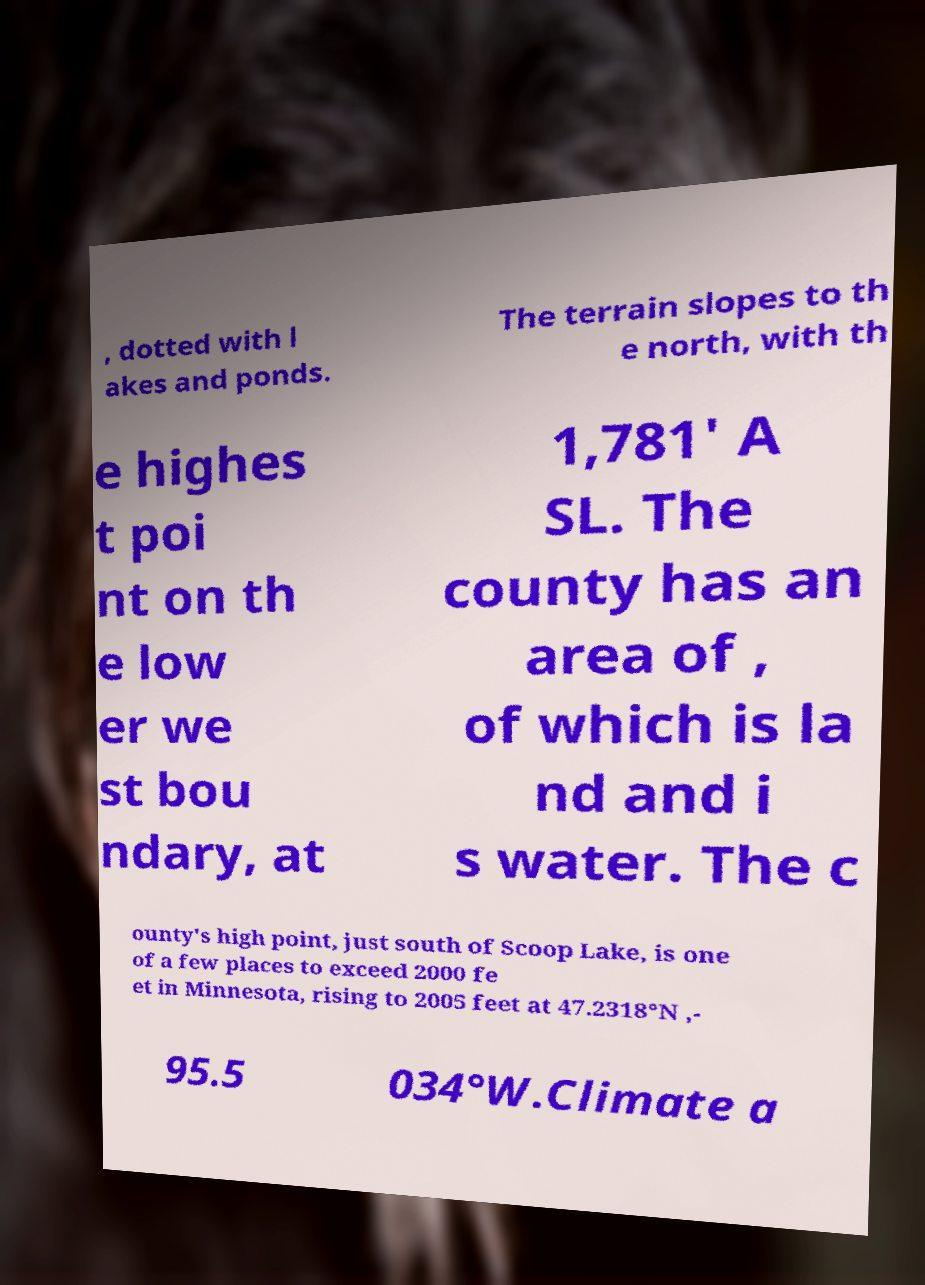Could you extract and type out the text from this image? , dotted with l akes and ponds. The terrain slopes to th e north, with th e highes t poi nt on th e low er we st bou ndary, at 1,781' A SL. The county has an area of , of which is la nd and i s water. The c ounty's high point, just south of Scoop Lake, is one of a few places to exceed 2000 fe et in Minnesota, rising to 2005 feet at 47.2318°N ,- 95.5 034°W.Climate a 